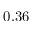Convert formula to latex. <formula><loc_0><loc_0><loc_500><loc_500>0 . 3 6</formula> 